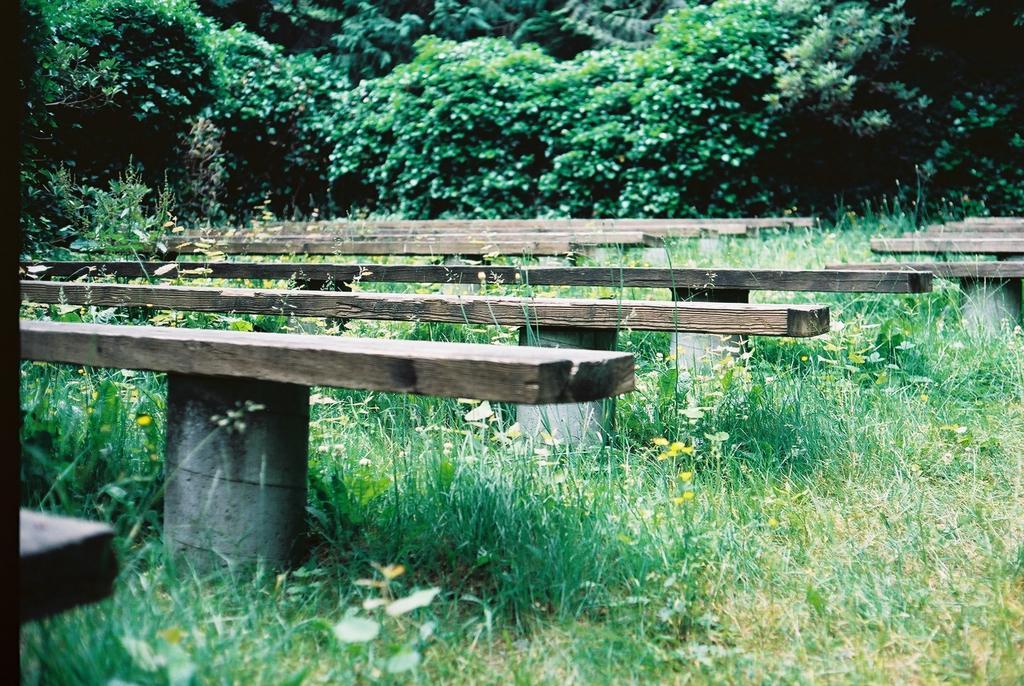Please provide a concise description of this image. In this image, we can see few benches with pillars. here we can see grass, flowers, plants. Background there are so many trees. 